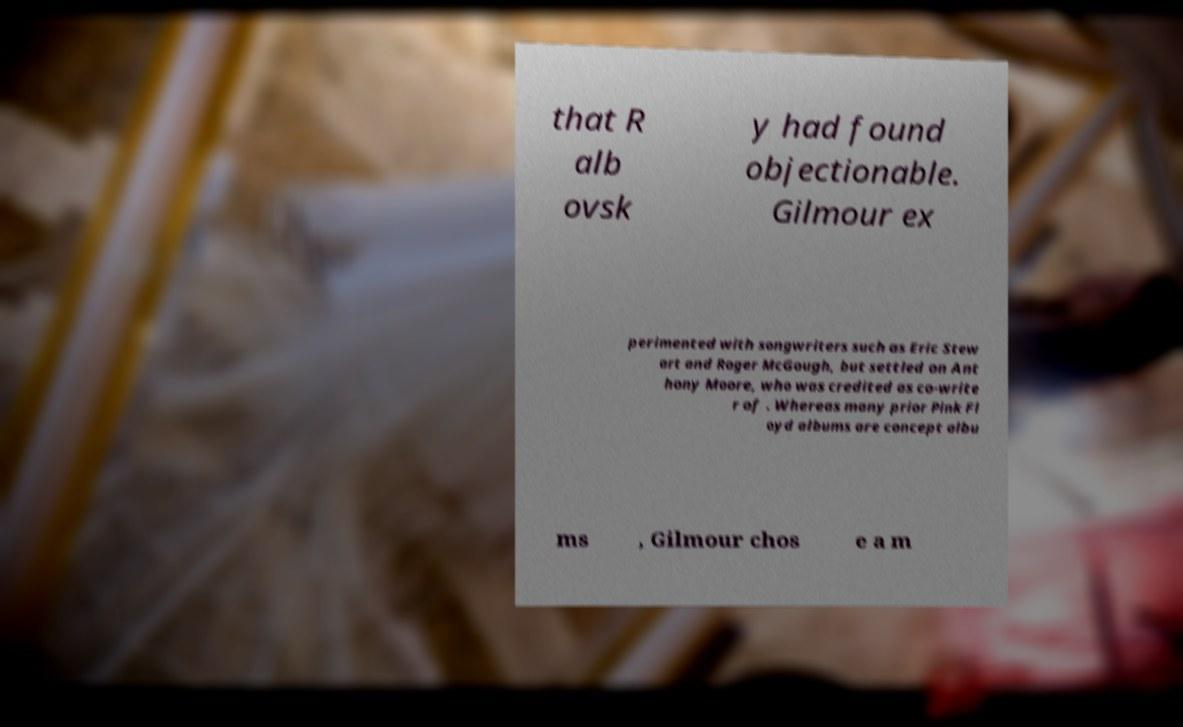I need the written content from this picture converted into text. Can you do that? that R alb ovsk y had found objectionable. Gilmour ex perimented with songwriters such as Eric Stew art and Roger McGough, but settled on Ant hony Moore, who was credited as co-write r of . Whereas many prior Pink Fl oyd albums are concept albu ms , Gilmour chos e a m 